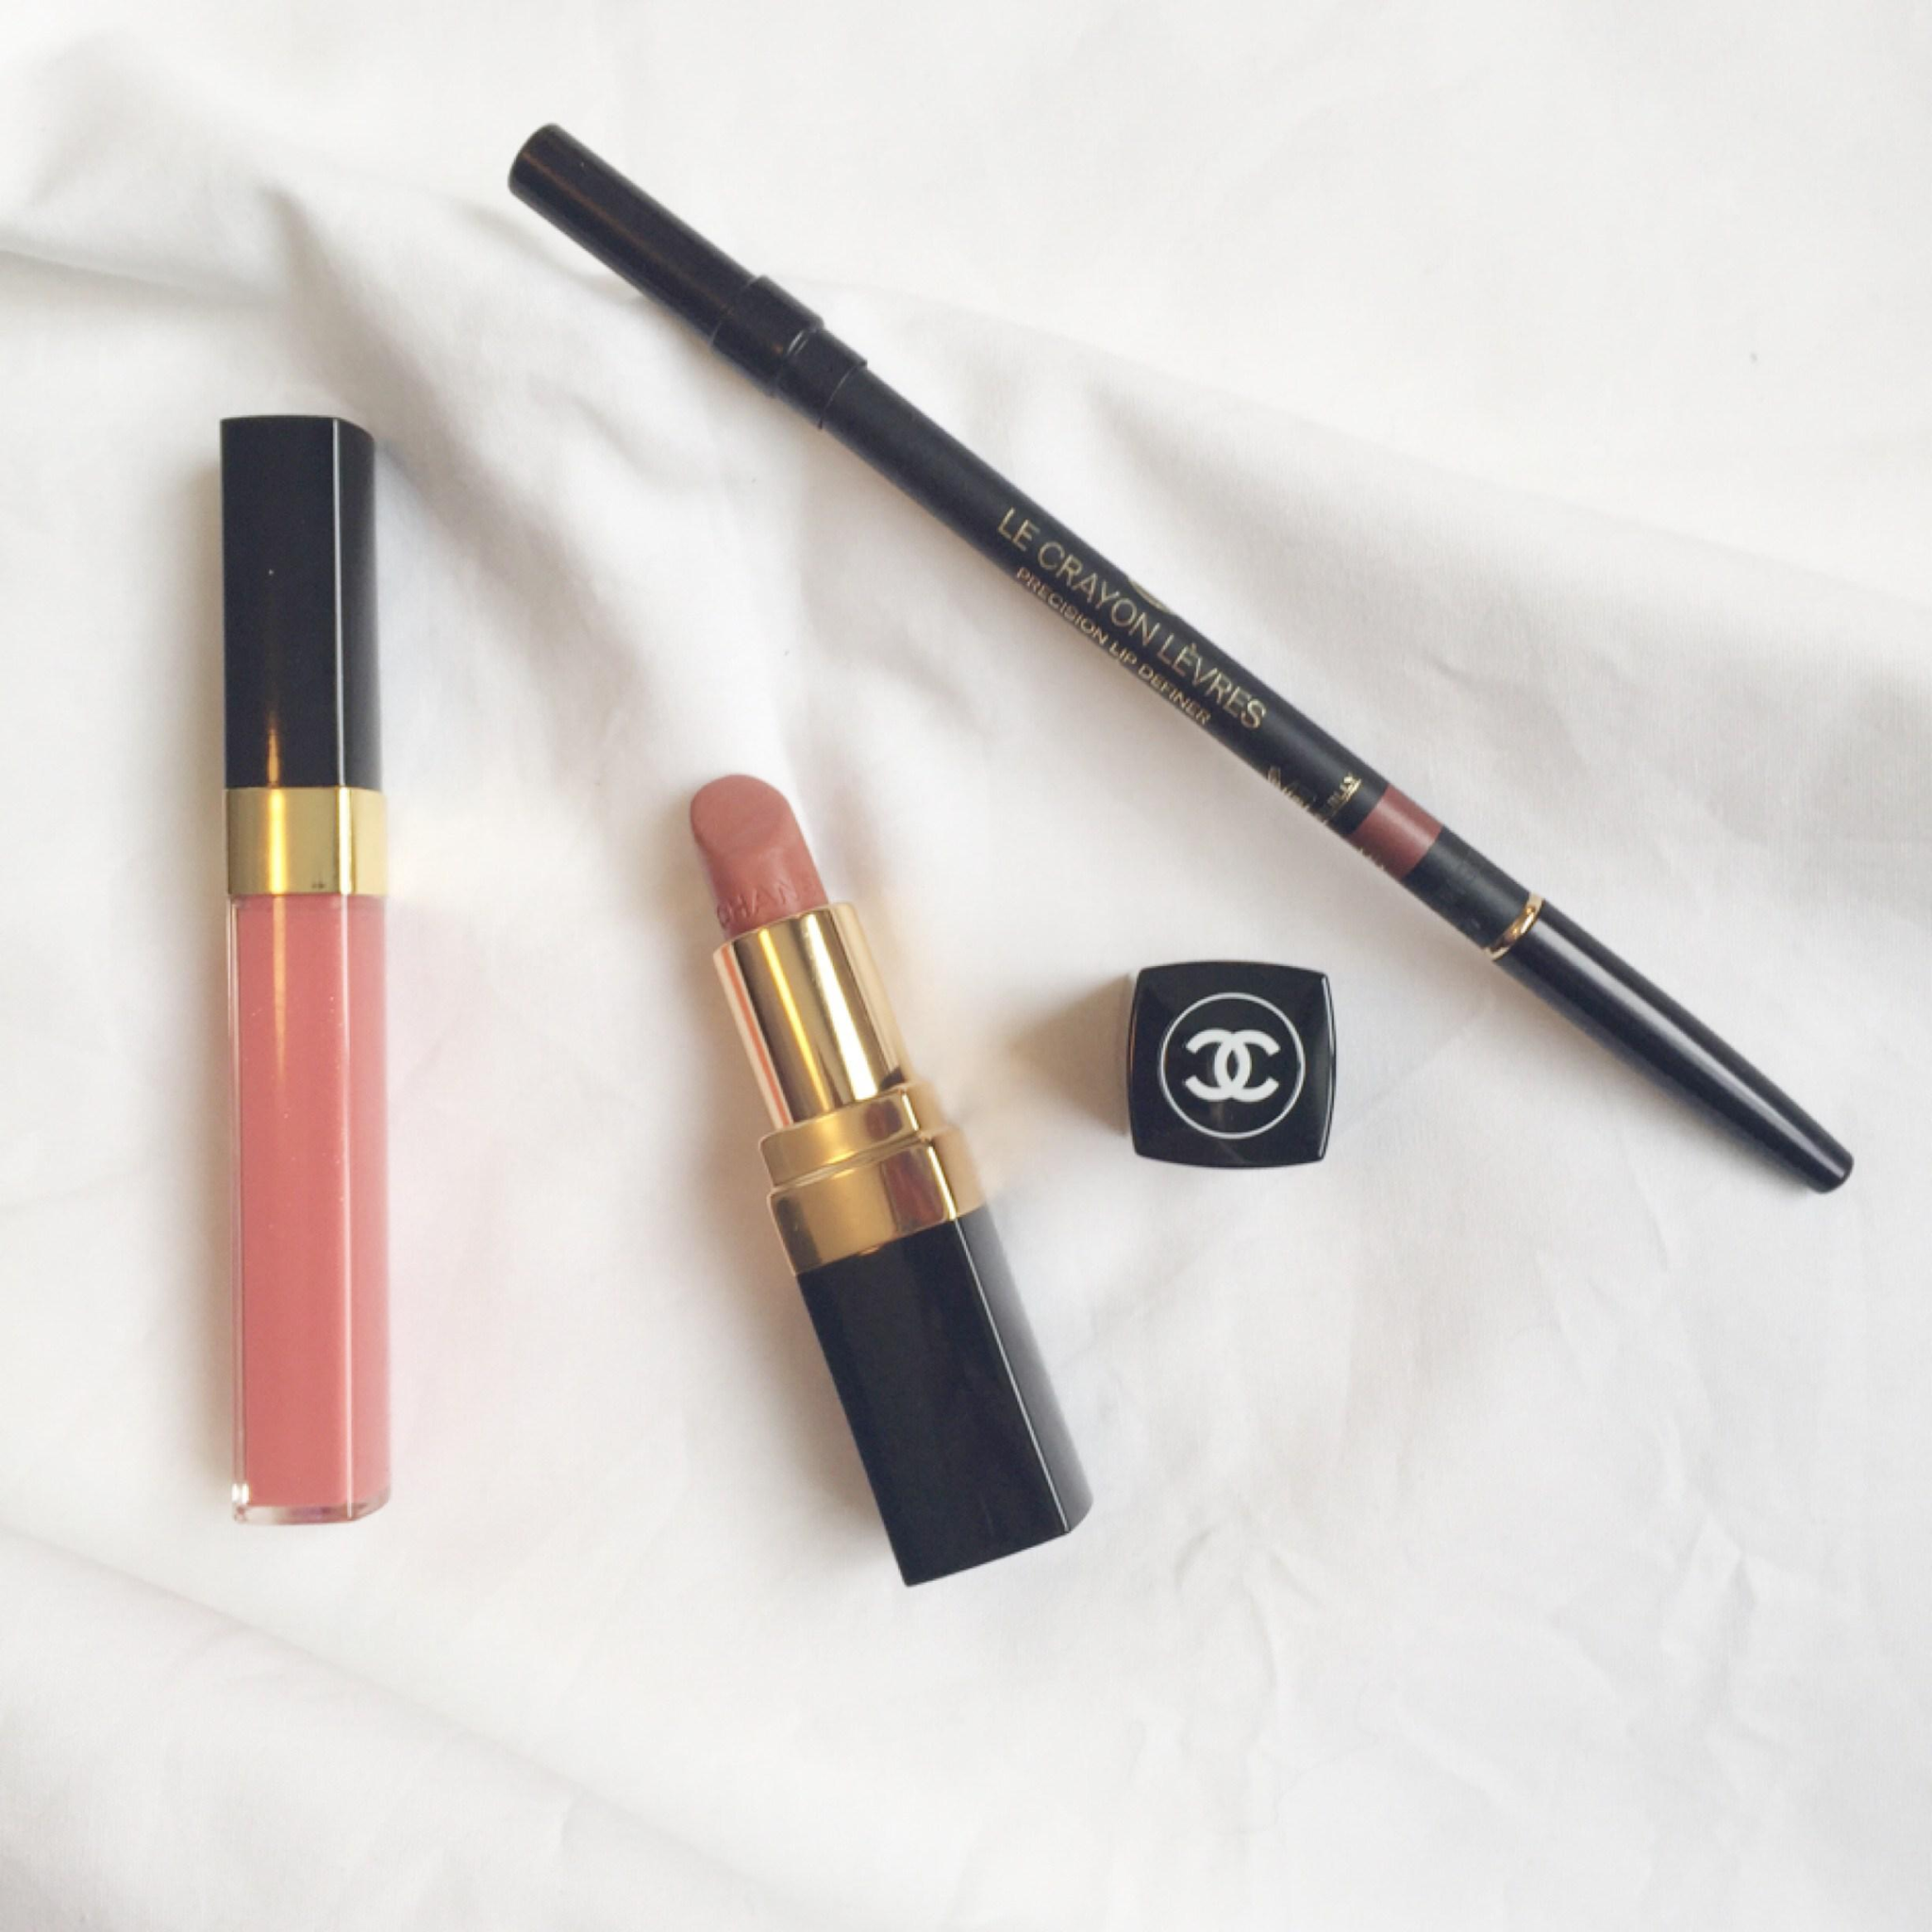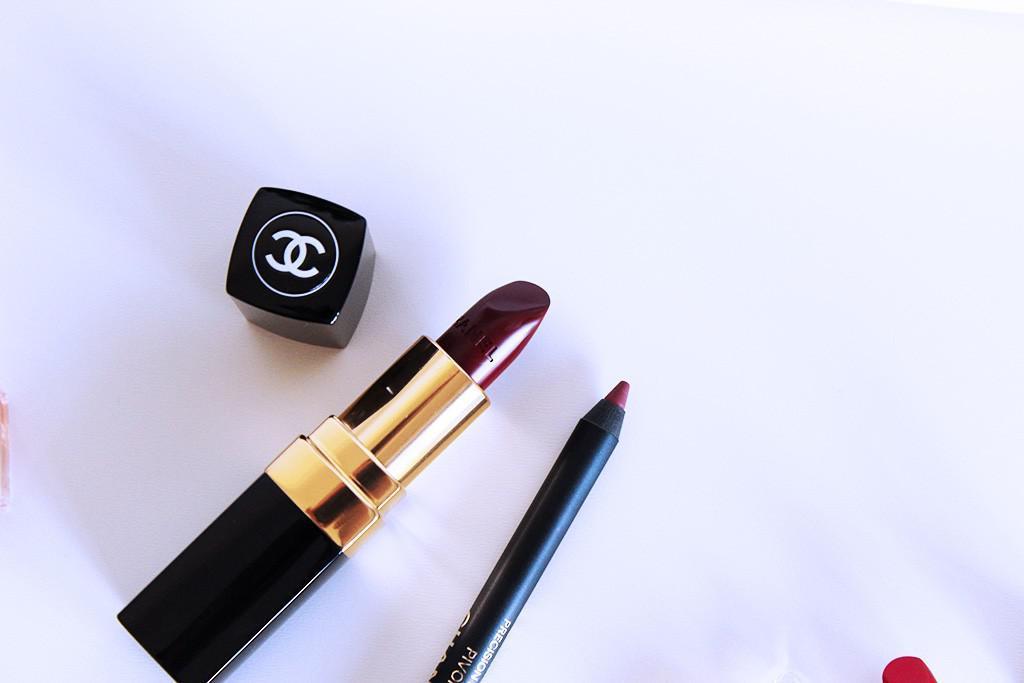The first image is the image on the left, the second image is the image on the right. Examine the images to the left and right. Is the description "An image with a lip pencil and lipstick includes a creamy colored flower." accurate? Answer yes or no. No. 